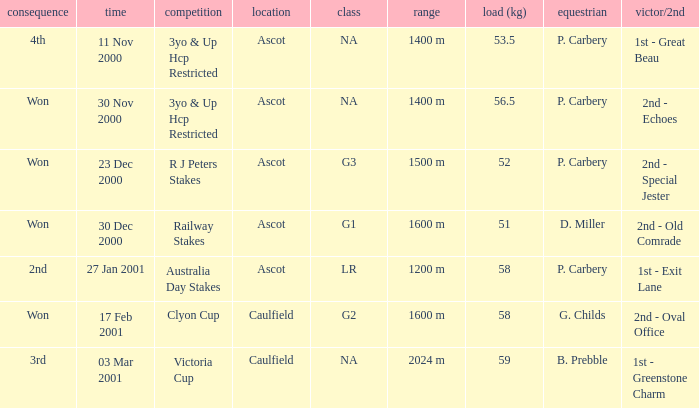What information can be found for the group with a 56.5 kg weight? NA. 